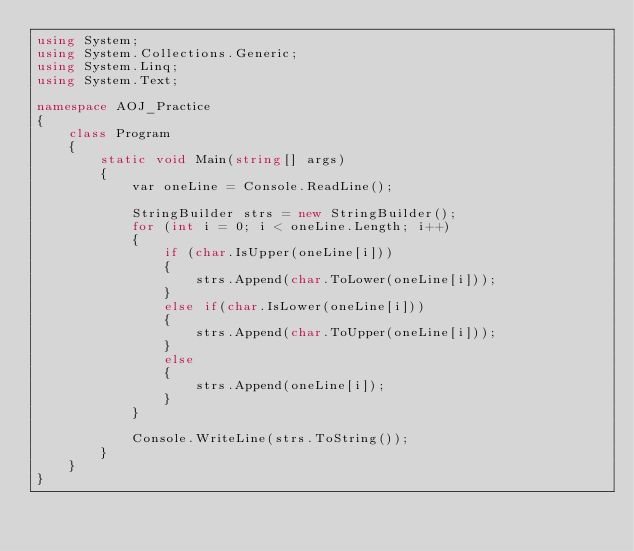Convert code to text. <code><loc_0><loc_0><loc_500><loc_500><_C#_>using System;
using System.Collections.Generic;
using System.Linq;
using System.Text;

namespace AOJ_Practice
{
    class Program
    {
        static void Main(string[] args)
        {
            var oneLine = Console.ReadLine();

            StringBuilder strs = new StringBuilder();
            for (int i = 0; i < oneLine.Length; i++)
            {
                if (char.IsUpper(oneLine[i]))
                {
                    strs.Append(char.ToLower(oneLine[i]));
                }
                else if(char.IsLower(oneLine[i]))
                {
                    strs.Append(char.ToUpper(oneLine[i]));
                }
                else
                {
                    strs.Append(oneLine[i]);
                }
            }

            Console.WriteLine(strs.ToString());
        }
    }
}

</code> 